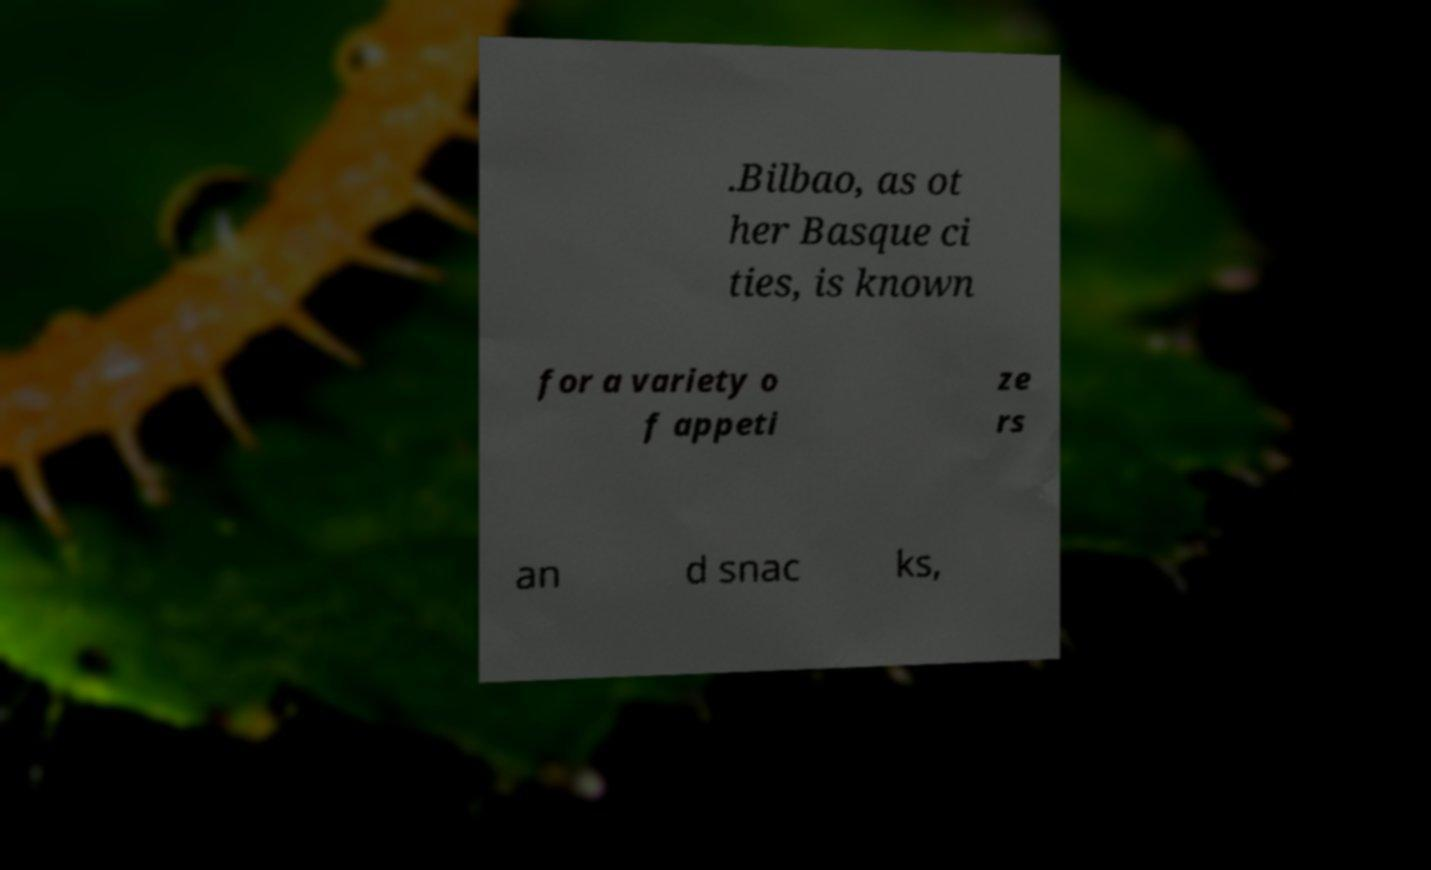Could you extract and type out the text from this image? .Bilbao, as ot her Basque ci ties, is known for a variety o f appeti ze rs an d snac ks, 